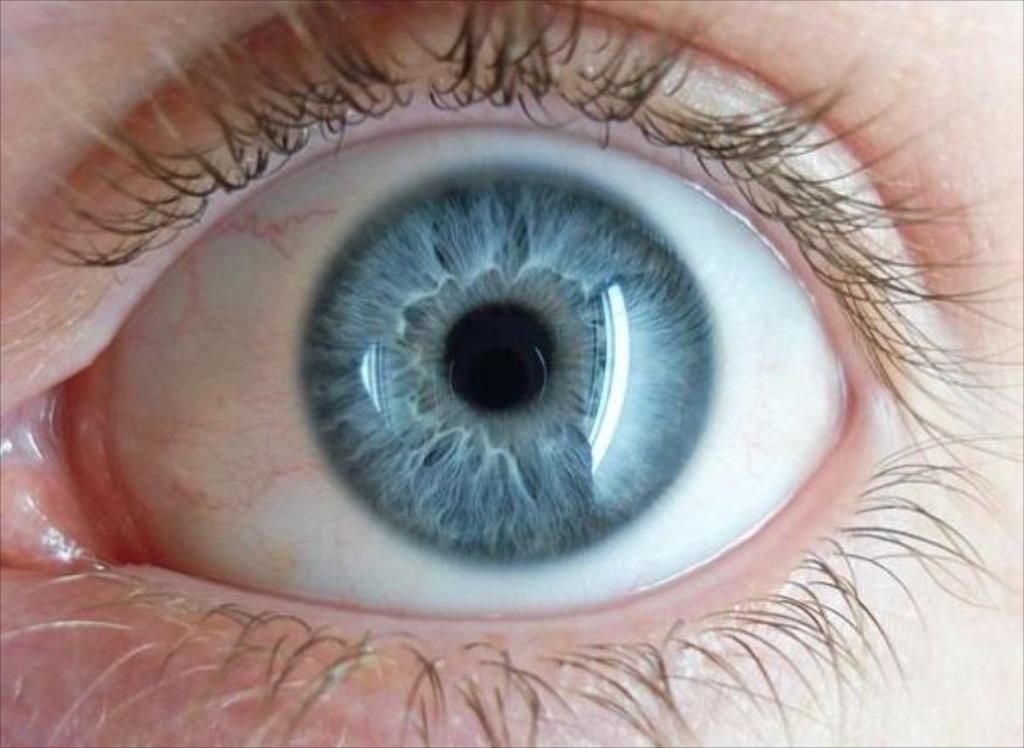Describe this image in one or two sentences. In this picture we can see an eye and eyelashes of a human. 